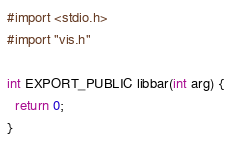<code> <loc_0><loc_0><loc_500><loc_500><_ObjectiveC_>#import <stdio.h>
#import "vis.h"

int EXPORT_PUBLIC libbar(int arg) {
  return 0;
}

</code> 